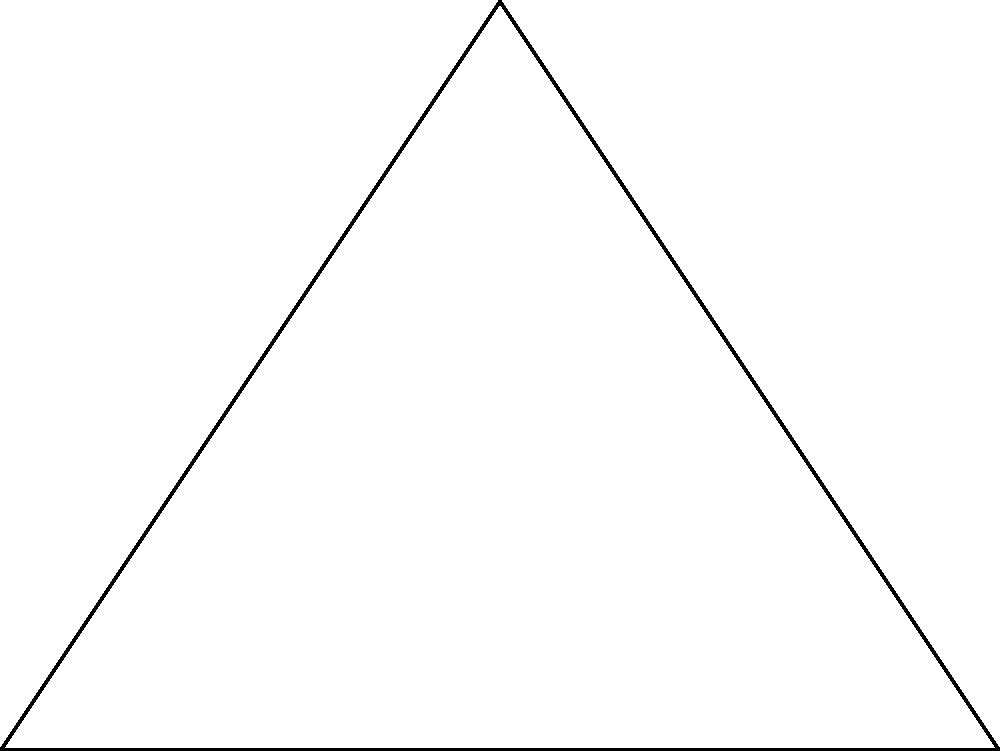In a wild west town, Sheriff Jim's badge is shaped like an inscribed circle within a triangular plate. The triangle's sides measure 4 cm, 5 cm, and 3 cm. What's the radius of the inscribed circle that forms the center of the badge? To find the radius of the inscribed circle, we'll follow these steps:

1) First, we need to calculate the semi-perimeter $s$ of the triangle:
   $s = \frac{a + b + c}{2} = \frac{4 + 5 + 3}{2} = 6$ cm

2) Now, we can use the formula for the area of the triangle:
   $A = \sqrt{s(s-a)(s-b)(s-c)}$
   
   Where $a$, $b$, and $c$ are the sides of the triangle.

3) Let's calculate the area:
   $A = \sqrt{6(6-4)(6-5)(6-3)} = \sqrt{6 \cdot 2 \cdot 1 \cdot 3} = \sqrt{36} = 6$ cm²

4) The radius of the inscribed circle is given by the formula:
   $r = \frac{A}{s}$

5) Substituting our values:
   $r = \frac{6}{6} = 1$ cm

Therefore, the radius of the inscribed circle (Sheriff Jim's badge center) is 1 cm.
Answer: 1 cm 